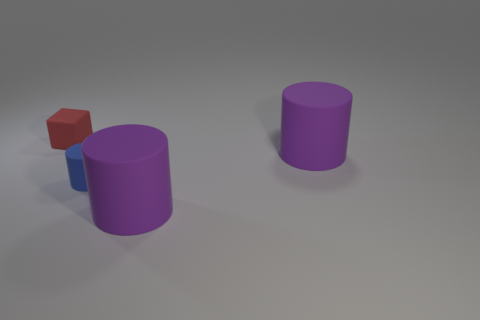Subtract all purple cubes. How many purple cylinders are left? 2 Add 1 cylinders. How many objects exist? 5 Subtract 1 cylinders. How many cylinders are left? 2 Subtract all blocks. How many objects are left? 3 Add 1 big brown cylinders. How many big brown cylinders exist? 1 Subtract 0 yellow spheres. How many objects are left? 4 Subtract all big rubber objects. Subtract all small blue matte objects. How many objects are left? 1 Add 2 small matte blocks. How many small matte blocks are left? 3 